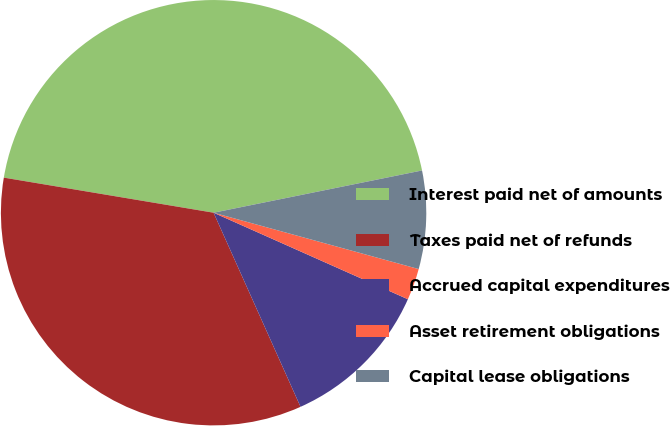Convert chart to OTSL. <chart><loc_0><loc_0><loc_500><loc_500><pie_chart><fcel>Interest paid net of amounts<fcel>Taxes paid net of refunds<fcel>Accrued capital expenditures<fcel>Asset retirement obligations<fcel>Capital lease obligations<nl><fcel>44.18%<fcel>34.34%<fcel>11.63%<fcel>2.4%<fcel>7.45%<nl></chart> 